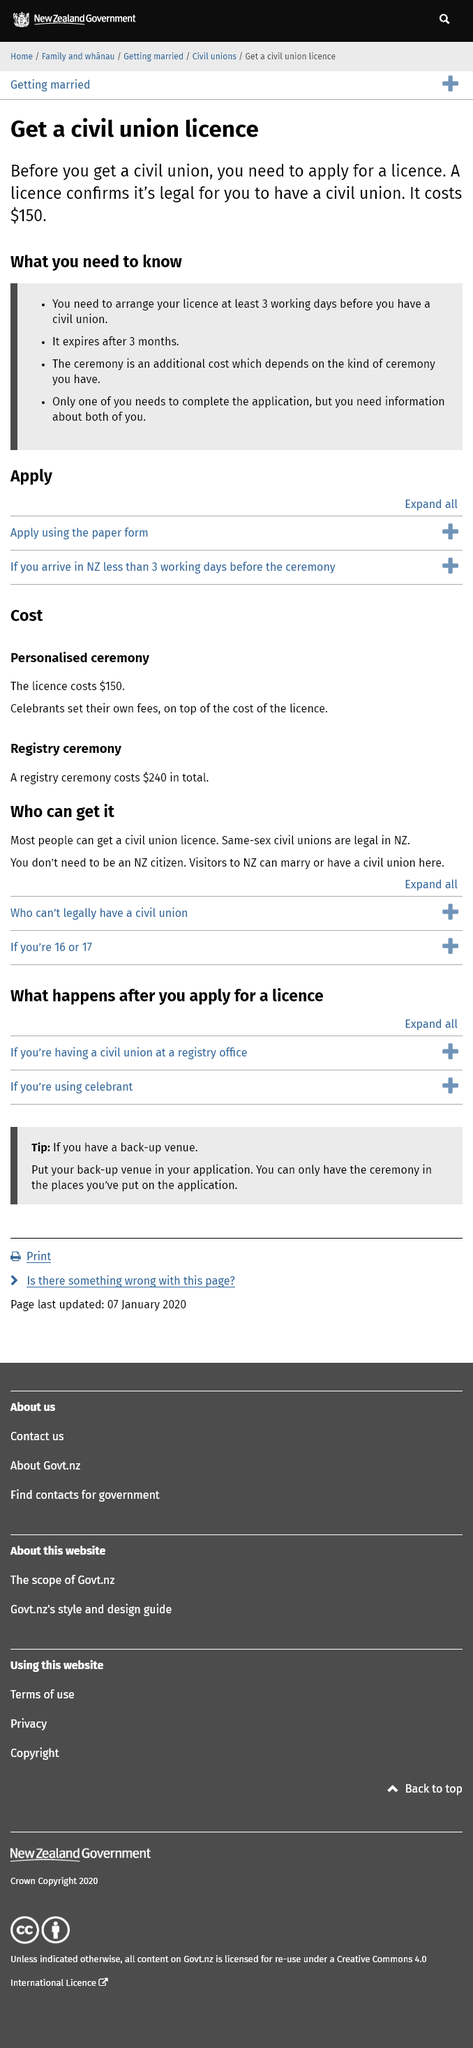Identify some key points in this picture. The cost of a civil union license is $150. A civil union license expires three months after issuance. In order to have a civil union, you must arrange your license for at least three working days prior to the ceremony. 